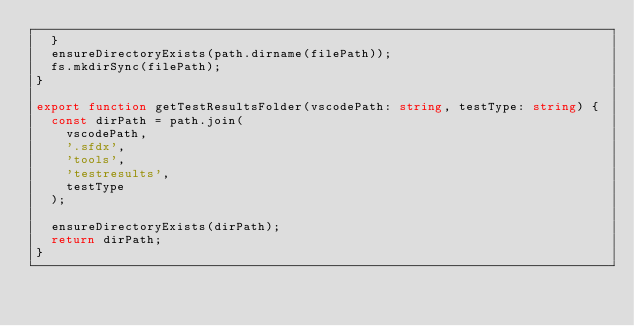Convert code to text. <code><loc_0><loc_0><loc_500><loc_500><_TypeScript_>  }
  ensureDirectoryExists(path.dirname(filePath));
  fs.mkdirSync(filePath);
}

export function getTestResultsFolder(vscodePath: string, testType: string) {
  const dirPath = path.join(
    vscodePath,
    '.sfdx',
    'tools',
    'testresults',
    testType
  );

  ensureDirectoryExists(dirPath);
  return dirPath;
}
</code> 